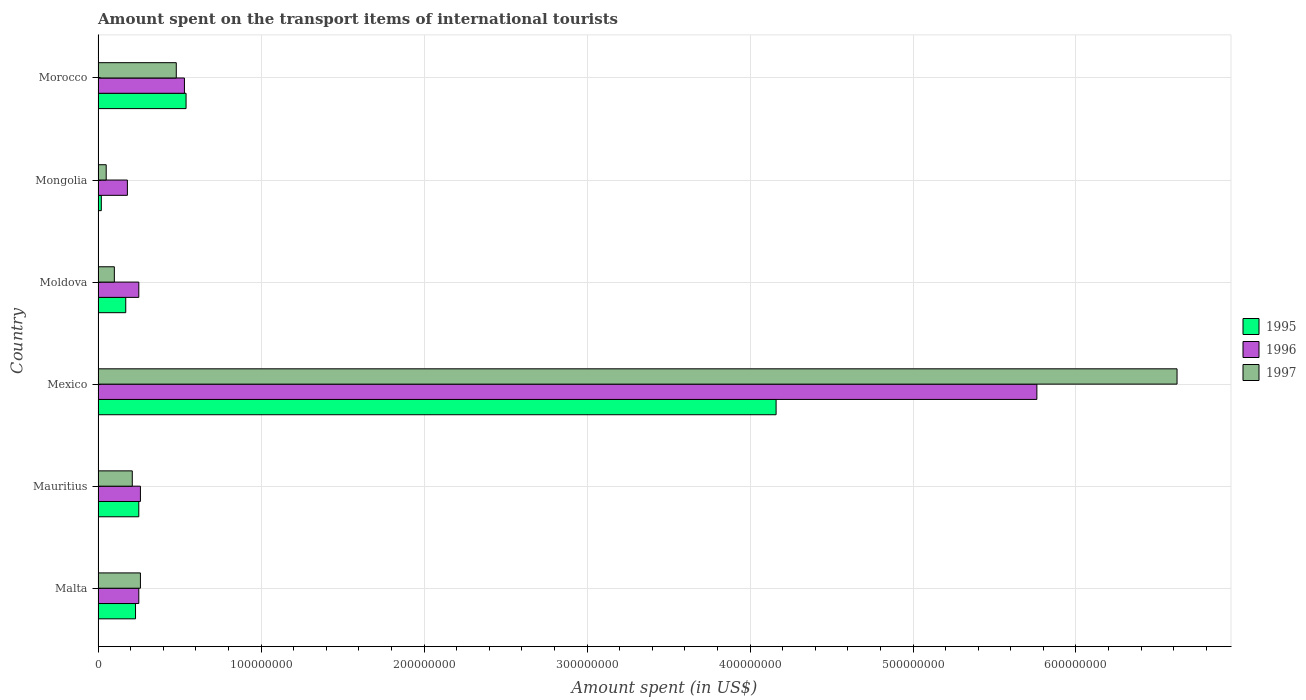How many different coloured bars are there?
Your answer should be compact. 3. Are the number of bars per tick equal to the number of legend labels?
Provide a succinct answer. Yes. How many bars are there on the 5th tick from the top?
Your response must be concise. 3. What is the label of the 6th group of bars from the top?
Your response must be concise. Malta. In how many cases, is the number of bars for a given country not equal to the number of legend labels?
Make the answer very short. 0. What is the amount spent on the transport items of international tourists in 1995 in Malta?
Your answer should be compact. 2.30e+07. Across all countries, what is the maximum amount spent on the transport items of international tourists in 1996?
Make the answer very short. 5.76e+08. Across all countries, what is the minimum amount spent on the transport items of international tourists in 1996?
Your answer should be compact. 1.80e+07. In which country was the amount spent on the transport items of international tourists in 1996 minimum?
Your response must be concise. Mongolia. What is the total amount spent on the transport items of international tourists in 1997 in the graph?
Offer a terse response. 7.72e+08. What is the difference between the amount spent on the transport items of international tourists in 1997 in Mongolia and that in Morocco?
Your answer should be compact. -4.30e+07. What is the difference between the amount spent on the transport items of international tourists in 1996 in Moldova and the amount spent on the transport items of international tourists in 1995 in Mongolia?
Provide a short and direct response. 2.30e+07. What is the average amount spent on the transport items of international tourists in 1997 per country?
Ensure brevity in your answer.  1.29e+08. In how many countries, is the amount spent on the transport items of international tourists in 1995 greater than 300000000 US$?
Ensure brevity in your answer.  1. Is the amount spent on the transport items of international tourists in 1995 in Mongolia less than that in Morocco?
Offer a very short reply. Yes. Is the difference between the amount spent on the transport items of international tourists in 1997 in Malta and Morocco greater than the difference between the amount spent on the transport items of international tourists in 1995 in Malta and Morocco?
Keep it short and to the point. Yes. What is the difference between the highest and the second highest amount spent on the transport items of international tourists in 1995?
Your response must be concise. 3.62e+08. What is the difference between the highest and the lowest amount spent on the transport items of international tourists in 1995?
Your response must be concise. 4.14e+08. In how many countries, is the amount spent on the transport items of international tourists in 1997 greater than the average amount spent on the transport items of international tourists in 1997 taken over all countries?
Your answer should be compact. 1. What does the 3rd bar from the top in Mexico represents?
Offer a very short reply. 1995. Are all the bars in the graph horizontal?
Offer a very short reply. Yes. Are the values on the major ticks of X-axis written in scientific E-notation?
Offer a terse response. No. What is the title of the graph?
Ensure brevity in your answer.  Amount spent on the transport items of international tourists. What is the label or title of the X-axis?
Your answer should be compact. Amount spent (in US$). What is the label or title of the Y-axis?
Give a very brief answer. Country. What is the Amount spent (in US$) of 1995 in Malta?
Ensure brevity in your answer.  2.30e+07. What is the Amount spent (in US$) in 1996 in Malta?
Your answer should be compact. 2.50e+07. What is the Amount spent (in US$) of 1997 in Malta?
Offer a terse response. 2.60e+07. What is the Amount spent (in US$) in 1995 in Mauritius?
Offer a terse response. 2.50e+07. What is the Amount spent (in US$) of 1996 in Mauritius?
Your answer should be compact. 2.60e+07. What is the Amount spent (in US$) in 1997 in Mauritius?
Your answer should be compact. 2.10e+07. What is the Amount spent (in US$) of 1995 in Mexico?
Offer a terse response. 4.16e+08. What is the Amount spent (in US$) in 1996 in Mexico?
Offer a terse response. 5.76e+08. What is the Amount spent (in US$) of 1997 in Mexico?
Give a very brief answer. 6.62e+08. What is the Amount spent (in US$) of 1995 in Moldova?
Your answer should be very brief. 1.70e+07. What is the Amount spent (in US$) of 1996 in Moldova?
Ensure brevity in your answer.  2.50e+07. What is the Amount spent (in US$) of 1995 in Mongolia?
Offer a very short reply. 2.00e+06. What is the Amount spent (in US$) of 1996 in Mongolia?
Your response must be concise. 1.80e+07. What is the Amount spent (in US$) of 1997 in Mongolia?
Your response must be concise. 5.00e+06. What is the Amount spent (in US$) of 1995 in Morocco?
Provide a short and direct response. 5.40e+07. What is the Amount spent (in US$) in 1996 in Morocco?
Your response must be concise. 5.30e+07. What is the Amount spent (in US$) in 1997 in Morocco?
Give a very brief answer. 4.80e+07. Across all countries, what is the maximum Amount spent (in US$) in 1995?
Your answer should be very brief. 4.16e+08. Across all countries, what is the maximum Amount spent (in US$) in 1996?
Provide a short and direct response. 5.76e+08. Across all countries, what is the maximum Amount spent (in US$) of 1997?
Provide a succinct answer. 6.62e+08. Across all countries, what is the minimum Amount spent (in US$) in 1995?
Your response must be concise. 2.00e+06. Across all countries, what is the minimum Amount spent (in US$) in 1996?
Offer a terse response. 1.80e+07. What is the total Amount spent (in US$) of 1995 in the graph?
Keep it short and to the point. 5.37e+08. What is the total Amount spent (in US$) in 1996 in the graph?
Ensure brevity in your answer.  7.23e+08. What is the total Amount spent (in US$) of 1997 in the graph?
Provide a succinct answer. 7.72e+08. What is the difference between the Amount spent (in US$) of 1997 in Malta and that in Mauritius?
Your response must be concise. 5.00e+06. What is the difference between the Amount spent (in US$) in 1995 in Malta and that in Mexico?
Ensure brevity in your answer.  -3.93e+08. What is the difference between the Amount spent (in US$) in 1996 in Malta and that in Mexico?
Keep it short and to the point. -5.51e+08. What is the difference between the Amount spent (in US$) in 1997 in Malta and that in Mexico?
Give a very brief answer. -6.36e+08. What is the difference between the Amount spent (in US$) in 1995 in Malta and that in Moldova?
Give a very brief answer. 6.00e+06. What is the difference between the Amount spent (in US$) of 1997 in Malta and that in Moldova?
Your answer should be very brief. 1.60e+07. What is the difference between the Amount spent (in US$) in 1995 in Malta and that in Mongolia?
Provide a succinct answer. 2.10e+07. What is the difference between the Amount spent (in US$) of 1997 in Malta and that in Mongolia?
Offer a very short reply. 2.10e+07. What is the difference between the Amount spent (in US$) of 1995 in Malta and that in Morocco?
Your answer should be very brief. -3.10e+07. What is the difference between the Amount spent (in US$) in 1996 in Malta and that in Morocco?
Offer a terse response. -2.80e+07. What is the difference between the Amount spent (in US$) of 1997 in Malta and that in Morocco?
Your response must be concise. -2.20e+07. What is the difference between the Amount spent (in US$) of 1995 in Mauritius and that in Mexico?
Offer a terse response. -3.91e+08. What is the difference between the Amount spent (in US$) in 1996 in Mauritius and that in Mexico?
Your answer should be very brief. -5.50e+08. What is the difference between the Amount spent (in US$) of 1997 in Mauritius and that in Mexico?
Offer a terse response. -6.41e+08. What is the difference between the Amount spent (in US$) in 1997 in Mauritius and that in Moldova?
Provide a short and direct response. 1.10e+07. What is the difference between the Amount spent (in US$) of 1995 in Mauritius and that in Mongolia?
Your answer should be compact. 2.30e+07. What is the difference between the Amount spent (in US$) of 1997 in Mauritius and that in Mongolia?
Offer a very short reply. 1.60e+07. What is the difference between the Amount spent (in US$) of 1995 in Mauritius and that in Morocco?
Offer a terse response. -2.90e+07. What is the difference between the Amount spent (in US$) in 1996 in Mauritius and that in Morocco?
Offer a very short reply. -2.70e+07. What is the difference between the Amount spent (in US$) in 1997 in Mauritius and that in Morocco?
Ensure brevity in your answer.  -2.70e+07. What is the difference between the Amount spent (in US$) of 1995 in Mexico and that in Moldova?
Offer a terse response. 3.99e+08. What is the difference between the Amount spent (in US$) of 1996 in Mexico and that in Moldova?
Provide a succinct answer. 5.51e+08. What is the difference between the Amount spent (in US$) in 1997 in Mexico and that in Moldova?
Give a very brief answer. 6.52e+08. What is the difference between the Amount spent (in US$) in 1995 in Mexico and that in Mongolia?
Provide a succinct answer. 4.14e+08. What is the difference between the Amount spent (in US$) in 1996 in Mexico and that in Mongolia?
Provide a succinct answer. 5.58e+08. What is the difference between the Amount spent (in US$) of 1997 in Mexico and that in Mongolia?
Give a very brief answer. 6.57e+08. What is the difference between the Amount spent (in US$) of 1995 in Mexico and that in Morocco?
Keep it short and to the point. 3.62e+08. What is the difference between the Amount spent (in US$) in 1996 in Mexico and that in Morocco?
Offer a very short reply. 5.23e+08. What is the difference between the Amount spent (in US$) in 1997 in Mexico and that in Morocco?
Offer a terse response. 6.14e+08. What is the difference between the Amount spent (in US$) in 1995 in Moldova and that in Mongolia?
Provide a succinct answer. 1.50e+07. What is the difference between the Amount spent (in US$) of 1996 in Moldova and that in Mongolia?
Your response must be concise. 7.00e+06. What is the difference between the Amount spent (in US$) in 1997 in Moldova and that in Mongolia?
Provide a short and direct response. 5.00e+06. What is the difference between the Amount spent (in US$) of 1995 in Moldova and that in Morocco?
Your answer should be compact. -3.70e+07. What is the difference between the Amount spent (in US$) in 1996 in Moldova and that in Morocco?
Ensure brevity in your answer.  -2.80e+07. What is the difference between the Amount spent (in US$) of 1997 in Moldova and that in Morocco?
Offer a terse response. -3.80e+07. What is the difference between the Amount spent (in US$) in 1995 in Mongolia and that in Morocco?
Offer a terse response. -5.20e+07. What is the difference between the Amount spent (in US$) of 1996 in Mongolia and that in Morocco?
Offer a terse response. -3.50e+07. What is the difference between the Amount spent (in US$) in 1997 in Mongolia and that in Morocco?
Keep it short and to the point. -4.30e+07. What is the difference between the Amount spent (in US$) in 1995 in Malta and the Amount spent (in US$) in 1996 in Mexico?
Offer a terse response. -5.53e+08. What is the difference between the Amount spent (in US$) of 1995 in Malta and the Amount spent (in US$) of 1997 in Mexico?
Your response must be concise. -6.39e+08. What is the difference between the Amount spent (in US$) in 1996 in Malta and the Amount spent (in US$) in 1997 in Mexico?
Offer a very short reply. -6.37e+08. What is the difference between the Amount spent (in US$) in 1995 in Malta and the Amount spent (in US$) in 1997 in Moldova?
Your response must be concise. 1.30e+07. What is the difference between the Amount spent (in US$) in 1996 in Malta and the Amount spent (in US$) in 1997 in Moldova?
Your answer should be compact. 1.50e+07. What is the difference between the Amount spent (in US$) in 1995 in Malta and the Amount spent (in US$) in 1997 in Mongolia?
Your response must be concise. 1.80e+07. What is the difference between the Amount spent (in US$) of 1996 in Malta and the Amount spent (in US$) of 1997 in Mongolia?
Provide a short and direct response. 2.00e+07. What is the difference between the Amount spent (in US$) of 1995 in Malta and the Amount spent (in US$) of 1996 in Morocco?
Keep it short and to the point. -3.00e+07. What is the difference between the Amount spent (in US$) in 1995 in Malta and the Amount spent (in US$) in 1997 in Morocco?
Offer a terse response. -2.50e+07. What is the difference between the Amount spent (in US$) in 1996 in Malta and the Amount spent (in US$) in 1997 in Morocco?
Your answer should be compact. -2.30e+07. What is the difference between the Amount spent (in US$) in 1995 in Mauritius and the Amount spent (in US$) in 1996 in Mexico?
Make the answer very short. -5.51e+08. What is the difference between the Amount spent (in US$) in 1995 in Mauritius and the Amount spent (in US$) in 1997 in Mexico?
Your answer should be compact. -6.37e+08. What is the difference between the Amount spent (in US$) in 1996 in Mauritius and the Amount spent (in US$) in 1997 in Mexico?
Your answer should be compact. -6.36e+08. What is the difference between the Amount spent (in US$) in 1995 in Mauritius and the Amount spent (in US$) in 1997 in Moldova?
Your answer should be compact. 1.50e+07. What is the difference between the Amount spent (in US$) in 1996 in Mauritius and the Amount spent (in US$) in 1997 in Moldova?
Make the answer very short. 1.60e+07. What is the difference between the Amount spent (in US$) of 1996 in Mauritius and the Amount spent (in US$) of 1997 in Mongolia?
Your answer should be very brief. 2.10e+07. What is the difference between the Amount spent (in US$) of 1995 in Mauritius and the Amount spent (in US$) of 1996 in Morocco?
Your answer should be compact. -2.80e+07. What is the difference between the Amount spent (in US$) of 1995 in Mauritius and the Amount spent (in US$) of 1997 in Morocco?
Ensure brevity in your answer.  -2.30e+07. What is the difference between the Amount spent (in US$) in 1996 in Mauritius and the Amount spent (in US$) in 1997 in Morocco?
Give a very brief answer. -2.20e+07. What is the difference between the Amount spent (in US$) in 1995 in Mexico and the Amount spent (in US$) in 1996 in Moldova?
Give a very brief answer. 3.91e+08. What is the difference between the Amount spent (in US$) of 1995 in Mexico and the Amount spent (in US$) of 1997 in Moldova?
Keep it short and to the point. 4.06e+08. What is the difference between the Amount spent (in US$) of 1996 in Mexico and the Amount spent (in US$) of 1997 in Moldova?
Offer a terse response. 5.66e+08. What is the difference between the Amount spent (in US$) in 1995 in Mexico and the Amount spent (in US$) in 1996 in Mongolia?
Keep it short and to the point. 3.98e+08. What is the difference between the Amount spent (in US$) of 1995 in Mexico and the Amount spent (in US$) of 1997 in Mongolia?
Your answer should be compact. 4.11e+08. What is the difference between the Amount spent (in US$) in 1996 in Mexico and the Amount spent (in US$) in 1997 in Mongolia?
Give a very brief answer. 5.71e+08. What is the difference between the Amount spent (in US$) of 1995 in Mexico and the Amount spent (in US$) of 1996 in Morocco?
Your answer should be compact. 3.63e+08. What is the difference between the Amount spent (in US$) of 1995 in Mexico and the Amount spent (in US$) of 1997 in Morocco?
Keep it short and to the point. 3.68e+08. What is the difference between the Amount spent (in US$) in 1996 in Mexico and the Amount spent (in US$) in 1997 in Morocco?
Keep it short and to the point. 5.28e+08. What is the difference between the Amount spent (in US$) in 1995 in Moldova and the Amount spent (in US$) in 1996 in Mongolia?
Your response must be concise. -1.00e+06. What is the difference between the Amount spent (in US$) of 1996 in Moldova and the Amount spent (in US$) of 1997 in Mongolia?
Your response must be concise. 2.00e+07. What is the difference between the Amount spent (in US$) in 1995 in Moldova and the Amount spent (in US$) in 1996 in Morocco?
Make the answer very short. -3.60e+07. What is the difference between the Amount spent (in US$) in 1995 in Moldova and the Amount spent (in US$) in 1997 in Morocco?
Offer a very short reply. -3.10e+07. What is the difference between the Amount spent (in US$) of 1996 in Moldova and the Amount spent (in US$) of 1997 in Morocco?
Provide a short and direct response. -2.30e+07. What is the difference between the Amount spent (in US$) of 1995 in Mongolia and the Amount spent (in US$) of 1996 in Morocco?
Offer a very short reply. -5.10e+07. What is the difference between the Amount spent (in US$) in 1995 in Mongolia and the Amount spent (in US$) in 1997 in Morocco?
Offer a terse response. -4.60e+07. What is the difference between the Amount spent (in US$) in 1996 in Mongolia and the Amount spent (in US$) in 1997 in Morocco?
Your answer should be compact. -3.00e+07. What is the average Amount spent (in US$) in 1995 per country?
Your answer should be very brief. 8.95e+07. What is the average Amount spent (in US$) of 1996 per country?
Your answer should be very brief. 1.20e+08. What is the average Amount spent (in US$) of 1997 per country?
Provide a short and direct response. 1.29e+08. What is the difference between the Amount spent (in US$) of 1995 and Amount spent (in US$) of 1996 in Malta?
Offer a terse response. -2.00e+06. What is the difference between the Amount spent (in US$) of 1996 and Amount spent (in US$) of 1997 in Malta?
Your answer should be compact. -1.00e+06. What is the difference between the Amount spent (in US$) in 1995 and Amount spent (in US$) in 1996 in Mauritius?
Give a very brief answer. -1.00e+06. What is the difference between the Amount spent (in US$) in 1995 and Amount spent (in US$) in 1997 in Mauritius?
Give a very brief answer. 4.00e+06. What is the difference between the Amount spent (in US$) in 1995 and Amount spent (in US$) in 1996 in Mexico?
Your answer should be very brief. -1.60e+08. What is the difference between the Amount spent (in US$) of 1995 and Amount spent (in US$) of 1997 in Mexico?
Make the answer very short. -2.46e+08. What is the difference between the Amount spent (in US$) of 1996 and Amount spent (in US$) of 1997 in Mexico?
Make the answer very short. -8.60e+07. What is the difference between the Amount spent (in US$) of 1995 and Amount spent (in US$) of 1996 in Moldova?
Make the answer very short. -8.00e+06. What is the difference between the Amount spent (in US$) of 1996 and Amount spent (in US$) of 1997 in Moldova?
Give a very brief answer. 1.50e+07. What is the difference between the Amount spent (in US$) in 1995 and Amount spent (in US$) in 1996 in Mongolia?
Provide a short and direct response. -1.60e+07. What is the difference between the Amount spent (in US$) in 1996 and Amount spent (in US$) in 1997 in Mongolia?
Provide a succinct answer. 1.30e+07. What is the difference between the Amount spent (in US$) of 1995 and Amount spent (in US$) of 1996 in Morocco?
Offer a terse response. 1.00e+06. What is the difference between the Amount spent (in US$) in 1995 and Amount spent (in US$) in 1997 in Morocco?
Make the answer very short. 6.00e+06. What is the ratio of the Amount spent (in US$) of 1995 in Malta to that in Mauritius?
Your answer should be compact. 0.92. What is the ratio of the Amount spent (in US$) in 1996 in Malta to that in Mauritius?
Your response must be concise. 0.96. What is the ratio of the Amount spent (in US$) of 1997 in Malta to that in Mauritius?
Your answer should be compact. 1.24. What is the ratio of the Amount spent (in US$) of 1995 in Malta to that in Mexico?
Provide a short and direct response. 0.06. What is the ratio of the Amount spent (in US$) in 1996 in Malta to that in Mexico?
Your answer should be very brief. 0.04. What is the ratio of the Amount spent (in US$) in 1997 in Malta to that in Mexico?
Provide a short and direct response. 0.04. What is the ratio of the Amount spent (in US$) in 1995 in Malta to that in Moldova?
Keep it short and to the point. 1.35. What is the ratio of the Amount spent (in US$) in 1996 in Malta to that in Moldova?
Your answer should be compact. 1. What is the ratio of the Amount spent (in US$) in 1997 in Malta to that in Moldova?
Provide a succinct answer. 2.6. What is the ratio of the Amount spent (in US$) in 1996 in Malta to that in Mongolia?
Ensure brevity in your answer.  1.39. What is the ratio of the Amount spent (in US$) of 1995 in Malta to that in Morocco?
Your answer should be very brief. 0.43. What is the ratio of the Amount spent (in US$) of 1996 in Malta to that in Morocco?
Make the answer very short. 0.47. What is the ratio of the Amount spent (in US$) in 1997 in Malta to that in Morocco?
Offer a very short reply. 0.54. What is the ratio of the Amount spent (in US$) in 1995 in Mauritius to that in Mexico?
Your answer should be compact. 0.06. What is the ratio of the Amount spent (in US$) in 1996 in Mauritius to that in Mexico?
Ensure brevity in your answer.  0.05. What is the ratio of the Amount spent (in US$) of 1997 in Mauritius to that in Mexico?
Give a very brief answer. 0.03. What is the ratio of the Amount spent (in US$) of 1995 in Mauritius to that in Moldova?
Provide a succinct answer. 1.47. What is the ratio of the Amount spent (in US$) in 1996 in Mauritius to that in Mongolia?
Provide a succinct answer. 1.44. What is the ratio of the Amount spent (in US$) in 1997 in Mauritius to that in Mongolia?
Offer a terse response. 4.2. What is the ratio of the Amount spent (in US$) of 1995 in Mauritius to that in Morocco?
Offer a very short reply. 0.46. What is the ratio of the Amount spent (in US$) of 1996 in Mauritius to that in Morocco?
Provide a succinct answer. 0.49. What is the ratio of the Amount spent (in US$) of 1997 in Mauritius to that in Morocco?
Your answer should be very brief. 0.44. What is the ratio of the Amount spent (in US$) of 1995 in Mexico to that in Moldova?
Offer a terse response. 24.47. What is the ratio of the Amount spent (in US$) of 1996 in Mexico to that in Moldova?
Give a very brief answer. 23.04. What is the ratio of the Amount spent (in US$) in 1997 in Mexico to that in Moldova?
Your answer should be very brief. 66.2. What is the ratio of the Amount spent (in US$) in 1995 in Mexico to that in Mongolia?
Your response must be concise. 208. What is the ratio of the Amount spent (in US$) in 1996 in Mexico to that in Mongolia?
Provide a succinct answer. 32. What is the ratio of the Amount spent (in US$) of 1997 in Mexico to that in Mongolia?
Your response must be concise. 132.4. What is the ratio of the Amount spent (in US$) in 1995 in Mexico to that in Morocco?
Make the answer very short. 7.7. What is the ratio of the Amount spent (in US$) of 1996 in Mexico to that in Morocco?
Offer a very short reply. 10.87. What is the ratio of the Amount spent (in US$) of 1997 in Mexico to that in Morocco?
Ensure brevity in your answer.  13.79. What is the ratio of the Amount spent (in US$) of 1996 in Moldova to that in Mongolia?
Your response must be concise. 1.39. What is the ratio of the Amount spent (in US$) of 1995 in Moldova to that in Morocco?
Keep it short and to the point. 0.31. What is the ratio of the Amount spent (in US$) of 1996 in Moldova to that in Morocco?
Offer a very short reply. 0.47. What is the ratio of the Amount spent (in US$) of 1997 in Moldova to that in Morocco?
Offer a terse response. 0.21. What is the ratio of the Amount spent (in US$) in 1995 in Mongolia to that in Morocco?
Provide a succinct answer. 0.04. What is the ratio of the Amount spent (in US$) of 1996 in Mongolia to that in Morocco?
Offer a very short reply. 0.34. What is the ratio of the Amount spent (in US$) in 1997 in Mongolia to that in Morocco?
Offer a very short reply. 0.1. What is the difference between the highest and the second highest Amount spent (in US$) in 1995?
Keep it short and to the point. 3.62e+08. What is the difference between the highest and the second highest Amount spent (in US$) in 1996?
Provide a succinct answer. 5.23e+08. What is the difference between the highest and the second highest Amount spent (in US$) in 1997?
Your answer should be very brief. 6.14e+08. What is the difference between the highest and the lowest Amount spent (in US$) of 1995?
Ensure brevity in your answer.  4.14e+08. What is the difference between the highest and the lowest Amount spent (in US$) of 1996?
Give a very brief answer. 5.58e+08. What is the difference between the highest and the lowest Amount spent (in US$) in 1997?
Offer a terse response. 6.57e+08. 